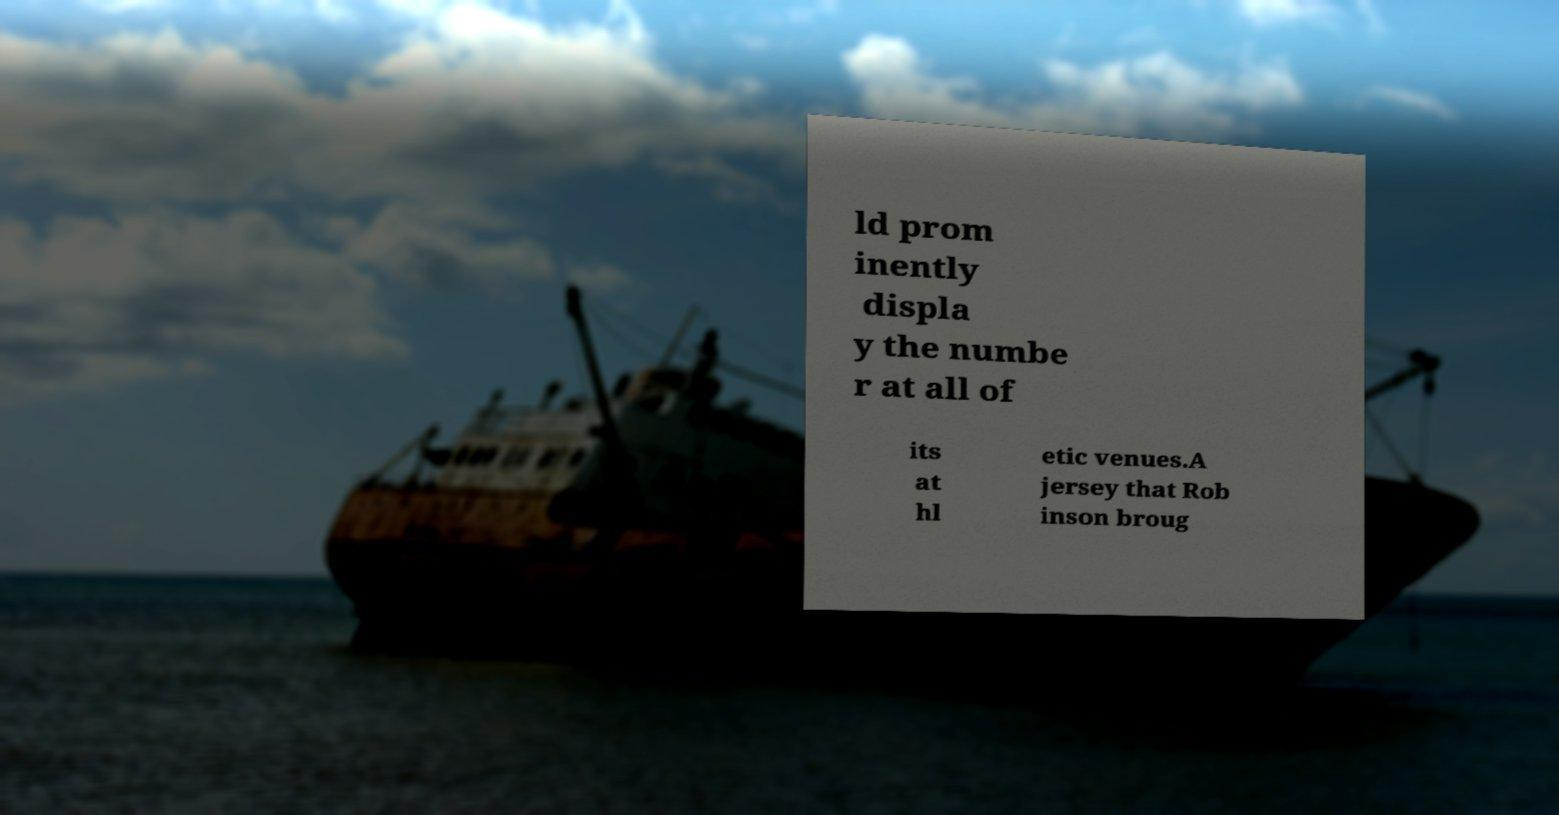What messages or text are displayed in this image? I need them in a readable, typed format. ld prom inently displa y the numbe r at all of its at hl etic venues.A jersey that Rob inson broug 